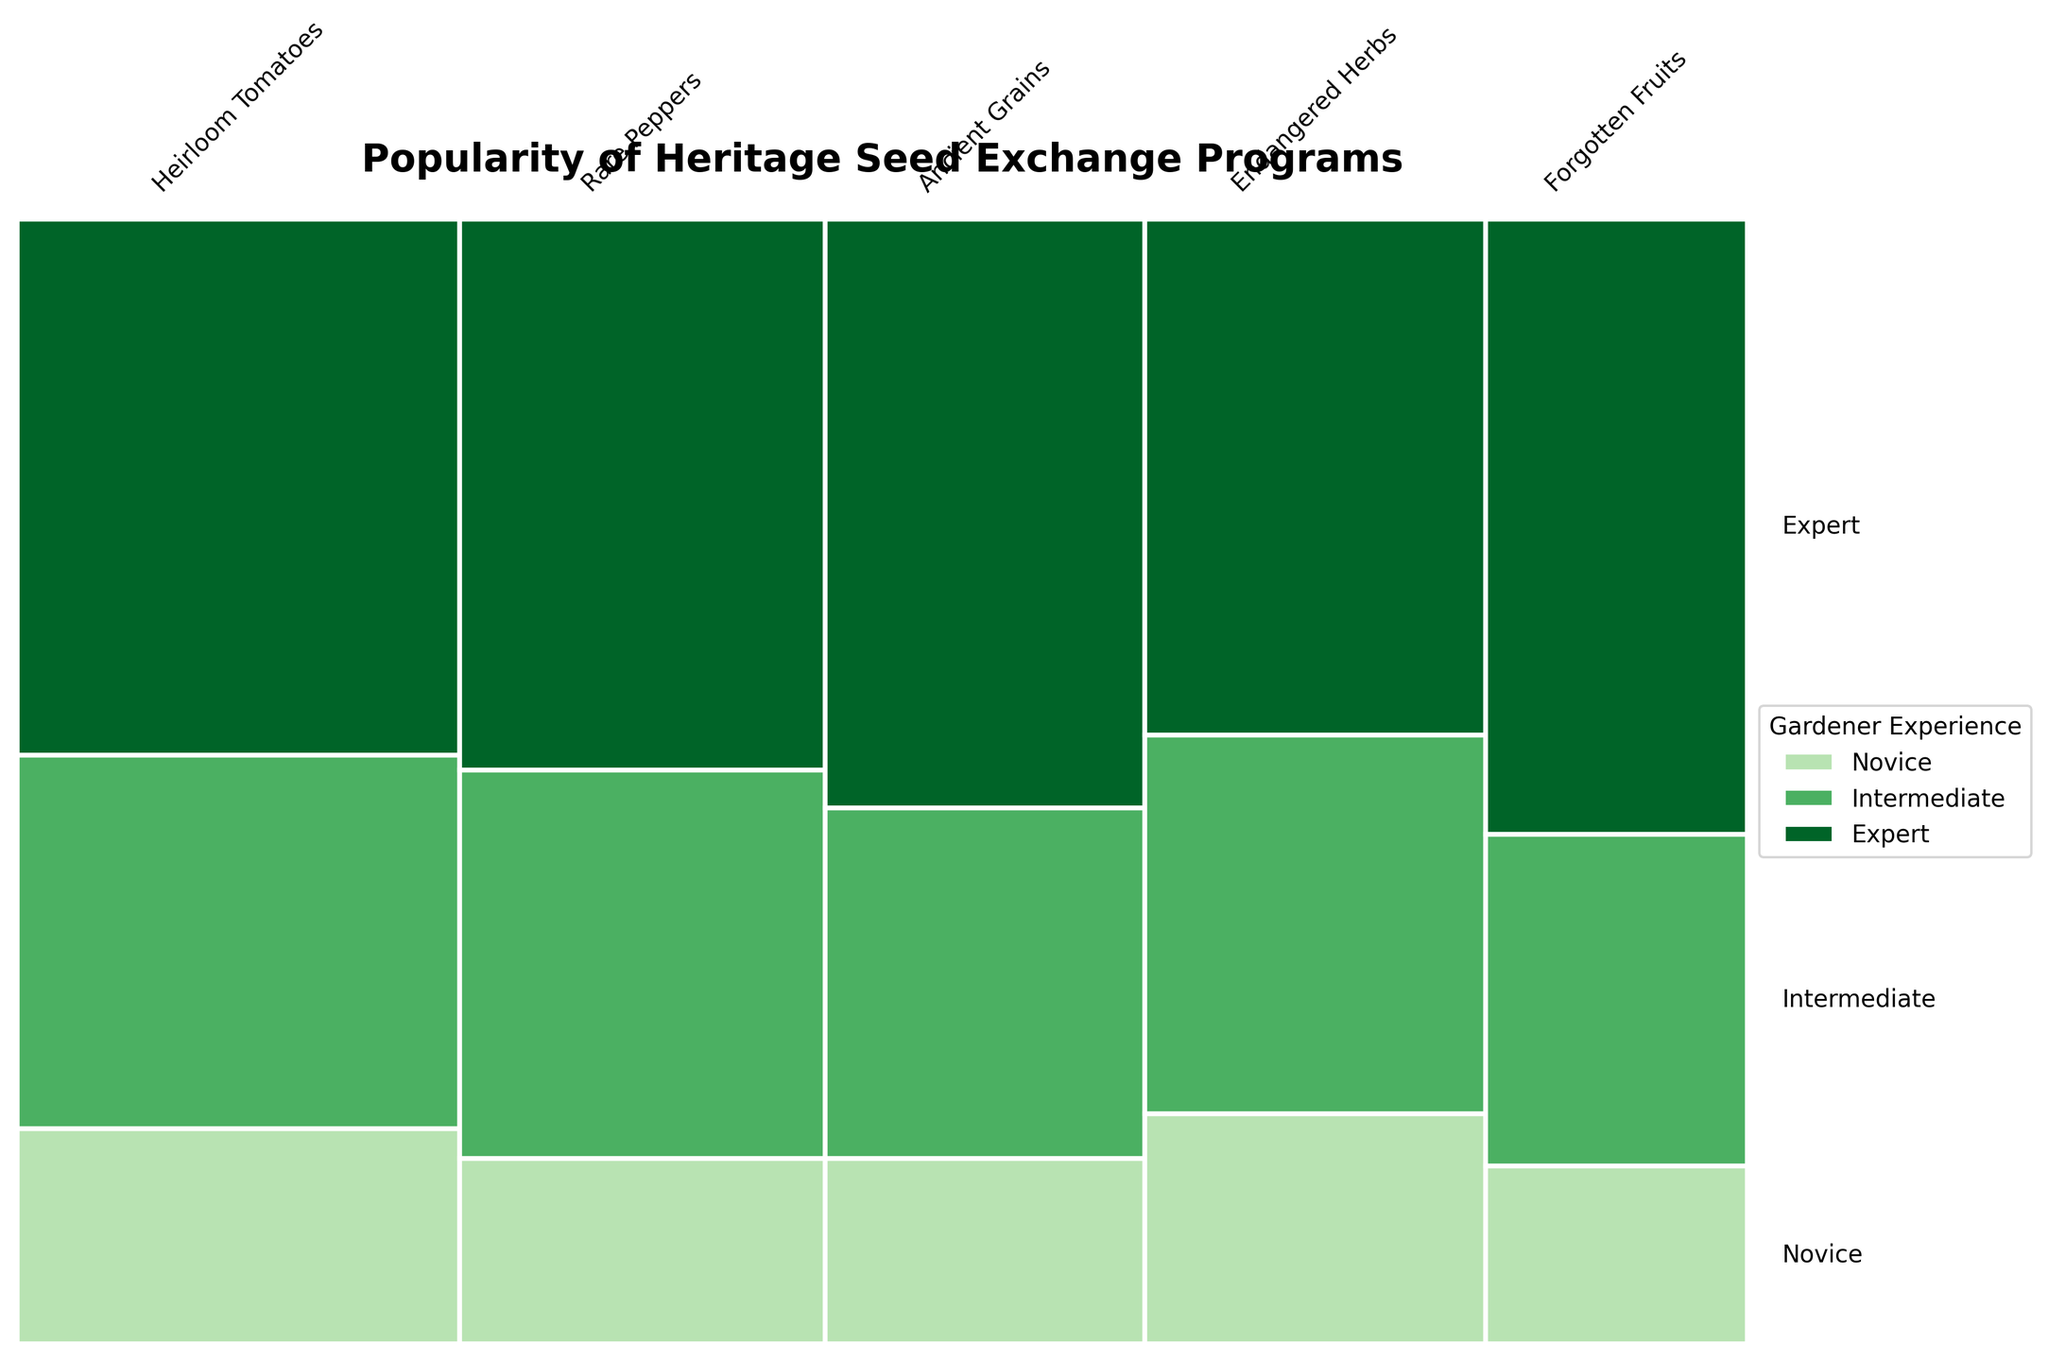What is the title of the plot? The title is typically located at the top of the plot, centered and in a larger font than other text elements. By looking at the top part of the plot, we can see the text clearly displayed as the title.
Answer: Popularity of Heritage Seed Exchange Programs Which rarity of seeds has the highest overall participation count? The width of the bars represents the overall participation counts for each seed rarity. The widest bar corresponds to the seed type with the highest participation count.
Answer: Heirloom Tomatoes For which gardener experience level is participation in the exchange program evenly split among different seed rarities? To determine this, we need to compare the heights of the sections within each column (representing a seed rarity) for each gardener experience level. If the heights are almost equal across seed rarities, the participation is evenly split.
Answer: Novice Which seed rarity is the least popular among novice gardeners? We need to examine the bottom sections of the bars, which represent novice gardeners. The smallest bottom section indicates the least participation by novice gardeners.
Answer: Forgotten Fruits How does the participation of expert gardeners compare to intermediate gardeners for Forgotten Fruits? We compare the heights of the sections for 'Expert' and 'Intermediate' within the column for Forgotten Fruits. The taller section between the two experience levels indicates higher participation.
Answer: Expert gardeners have more participation than intermediate gardeners for Forgotten Fruits Which gardener experience level has the widest range of participation across different seed rarities? The range of participation can be measured by the height difference between the tallest and shortest sections for each experience level across all seed rarities. The experience level with the largest difference has the widest range of participation.
Answer: Expert What is the combined participation count for novice gardeners across all seed rarities? We need to sum the sections representing novice gardeners for each seed rarity. By adding up the respective bottom sections' counts provided in the data, we calculate the combined participation. (45 + 32 + 28 + 37 + 22 = 164)
Answer: 164 Compare the total participation counts of Rare Peppers and Ancient Grains. Which is higher? We look at the widths of the bars corresponding to Rare Peppers and Ancient Grains. The wider bar indicates a higher total participation count.
Answer: Rare Peppers Are there any seed rarities where expert gardeners are not the majority participants? By examining the top sections of each bar, we check if any bar does not have expert gardeners as the tallest section.
Answer: No What seed rarity has the largest proportion of intermediate gardeners? The color representing intermediate gardeners is compared across all seed rarities. The bar with the largest portion of the intermediate gardener section indicates the seed rarity with the largest proportion.
Answer: Heirloom Tomatoes 